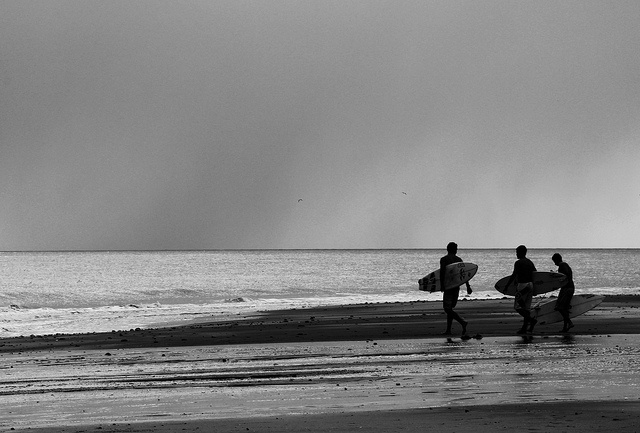Describe the objects in this image and their specific colors. I can see people in gray, black, darkgray, and lightgray tones, people in gray, black, darkgray, and lightgray tones, surfboard in gray, black, darkgray, and lightgray tones, surfboard in gray, black, and lightgray tones, and people in gray, black, darkgray, and lightgray tones in this image. 